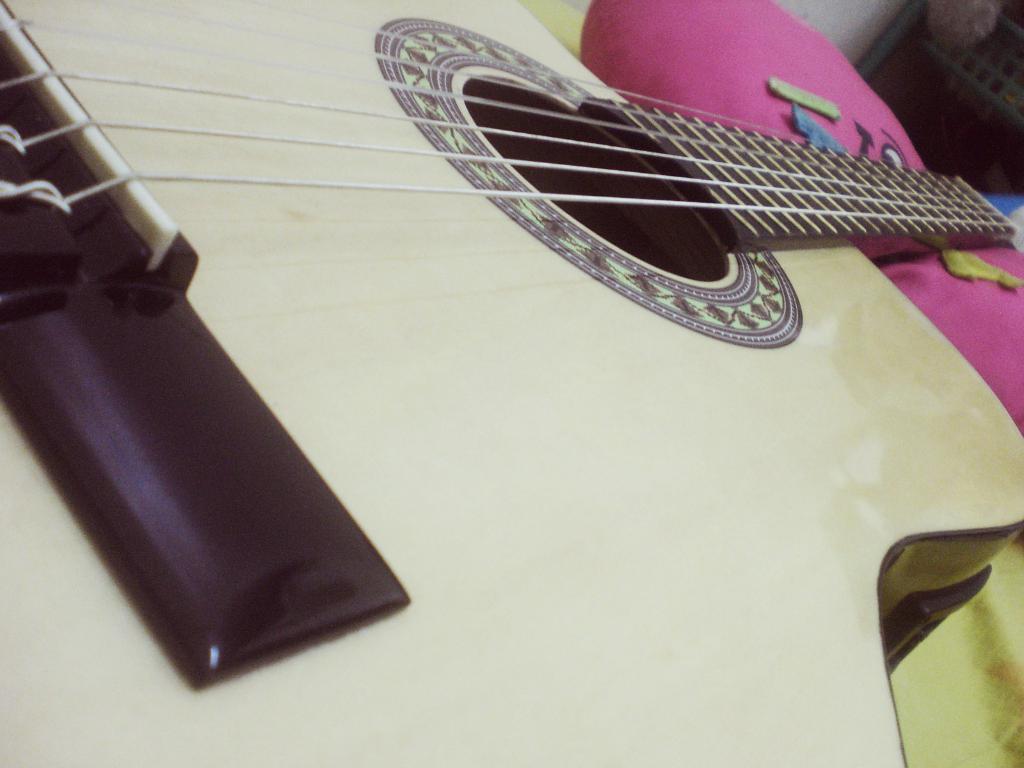Could you give a brief overview of what you see in this image? In this image i can see a guitar and a pillow. 